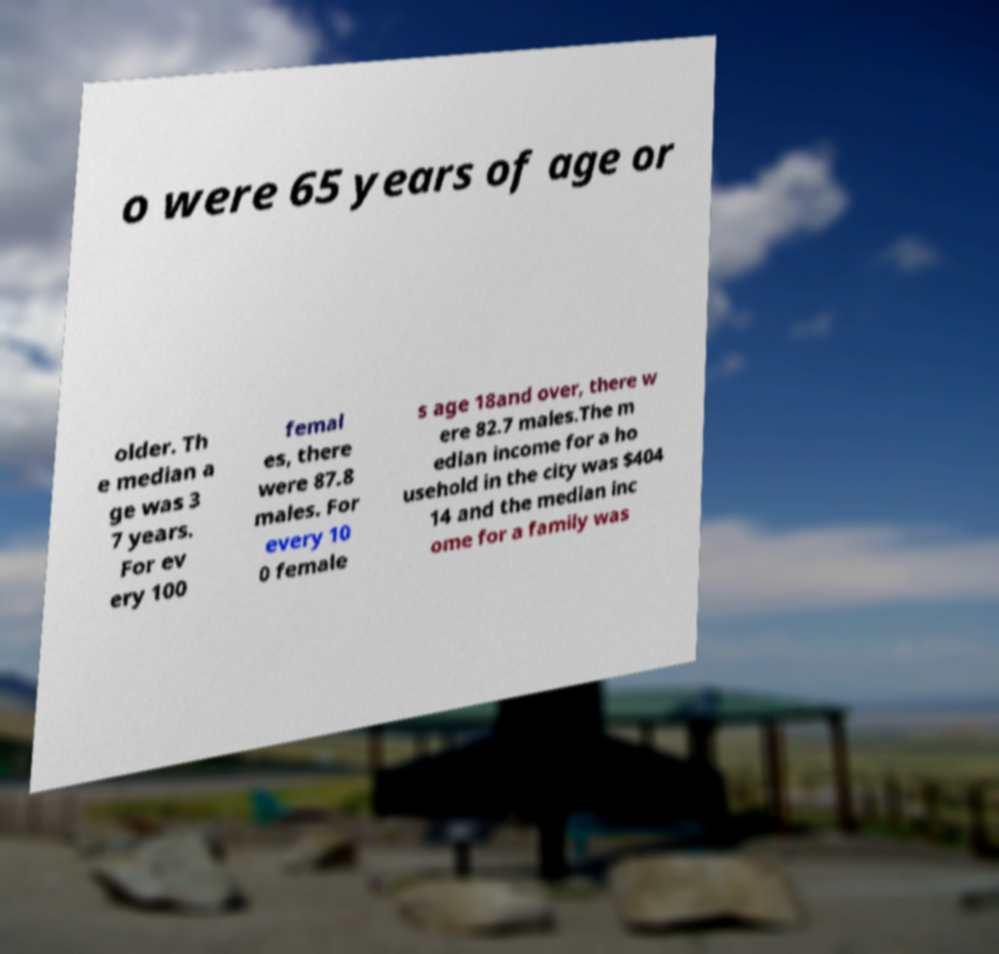Please read and relay the text visible in this image. What does it say? o were 65 years of age or older. Th e median a ge was 3 7 years. For ev ery 100 femal es, there were 87.8 males. For every 10 0 female s age 18and over, there w ere 82.7 males.The m edian income for a ho usehold in the city was $404 14 and the median inc ome for a family was 